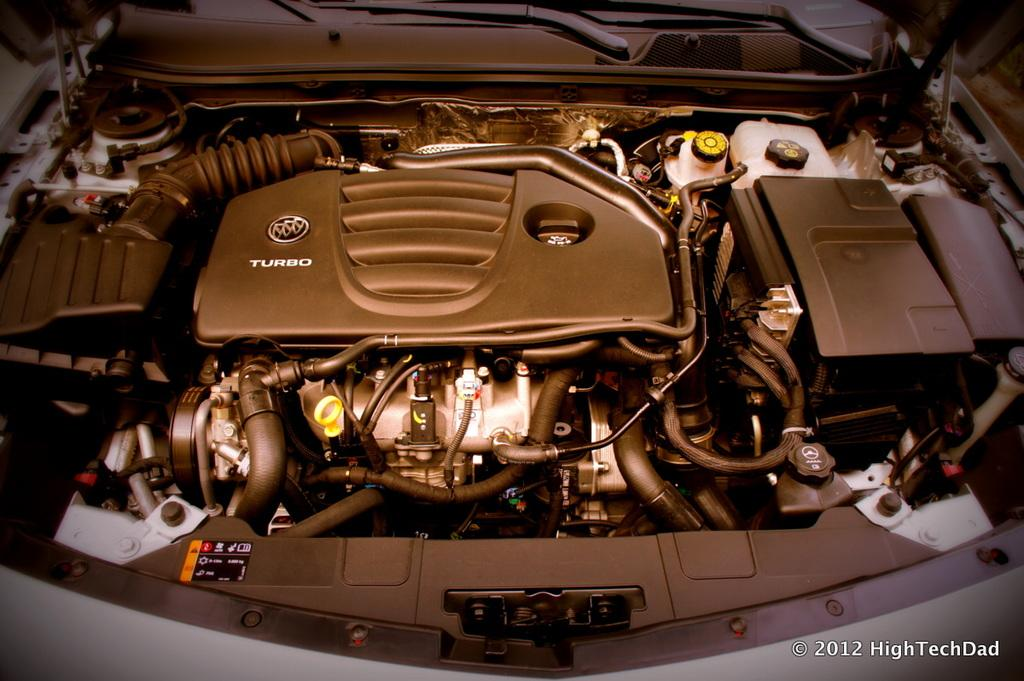<image>
Summarize the visual content of the image. Car with the hood open showing an engine that says "Turbo". 